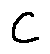Convert formula to latex. <formula><loc_0><loc_0><loc_500><loc_500>c</formula> 